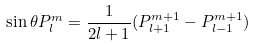Convert formula to latex. <formula><loc_0><loc_0><loc_500><loc_500>\sin \theta P _ { l } ^ { m } = \frac { 1 } { 2 l + 1 } ( P _ { l + 1 } ^ { m + 1 } - P _ { l - 1 } ^ { m + 1 } )</formula> 